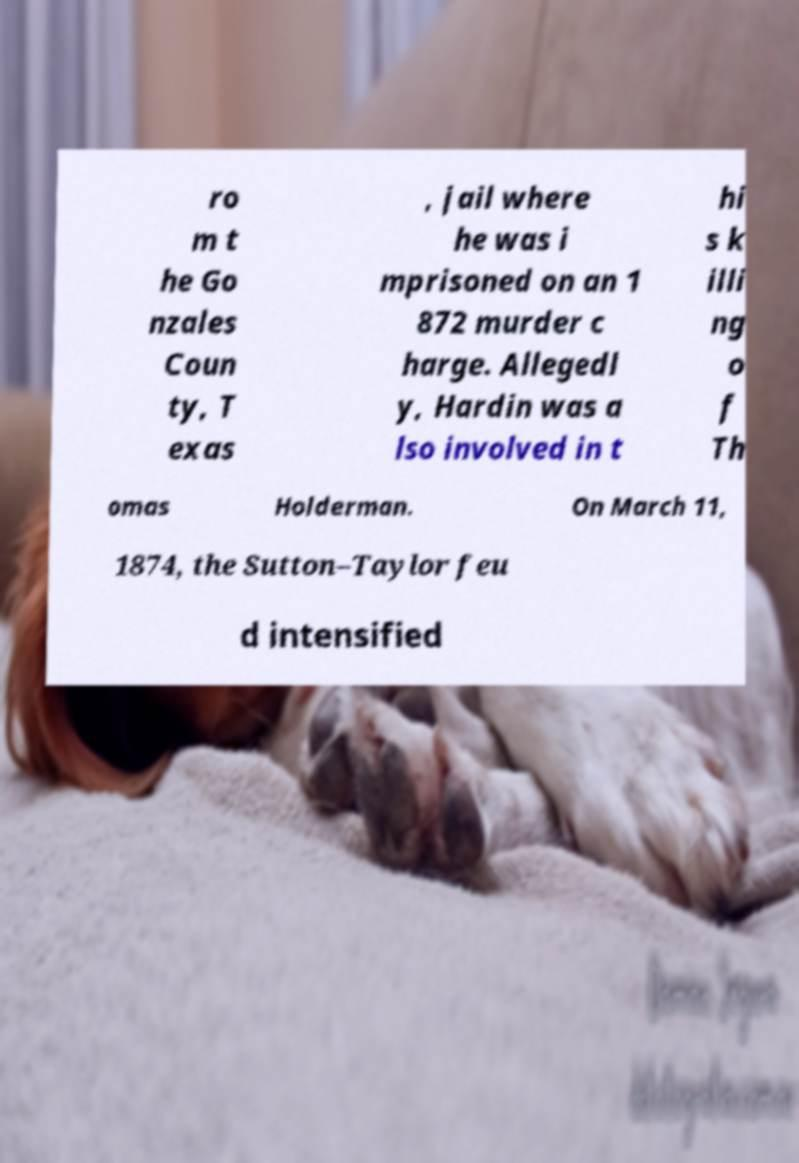There's text embedded in this image that I need extracted. Can you transcribe it verbatim? ro m t he Go nzales Coun ty, T exas , jail where he was i mprisoned on an 1 872 murder c harge. Allegedl y, Hardin was a lso involved in t hi s k illi ng o f Th omas Holderman. On March 11, 1874, the Sutton–Taylor feu d intensified 